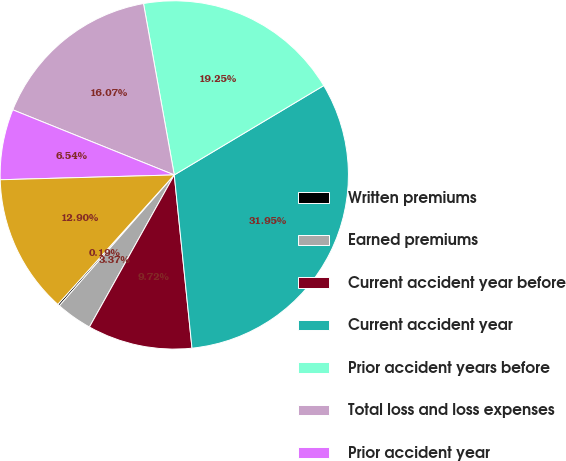Convert chart. <chart><loc_0><loc_0><loc_500><loc_500><pie_chart><fcel>Written premiums<fcel>Earned premiums<fcel>Current accident year before<fcel>Current accident year<fcel>Prior accident years before<fcel>Total loss and loss expenses<fcel>Prior accident year<fcel>Total loss and loss expense<nl><fcel>0.19%<fcel>3.37%<fcel>9.72%<fcel>31.95%<fcel>19.25%<fcel>16.07%<fcel>6.54%<fcel>12.9%<nl></chart> 